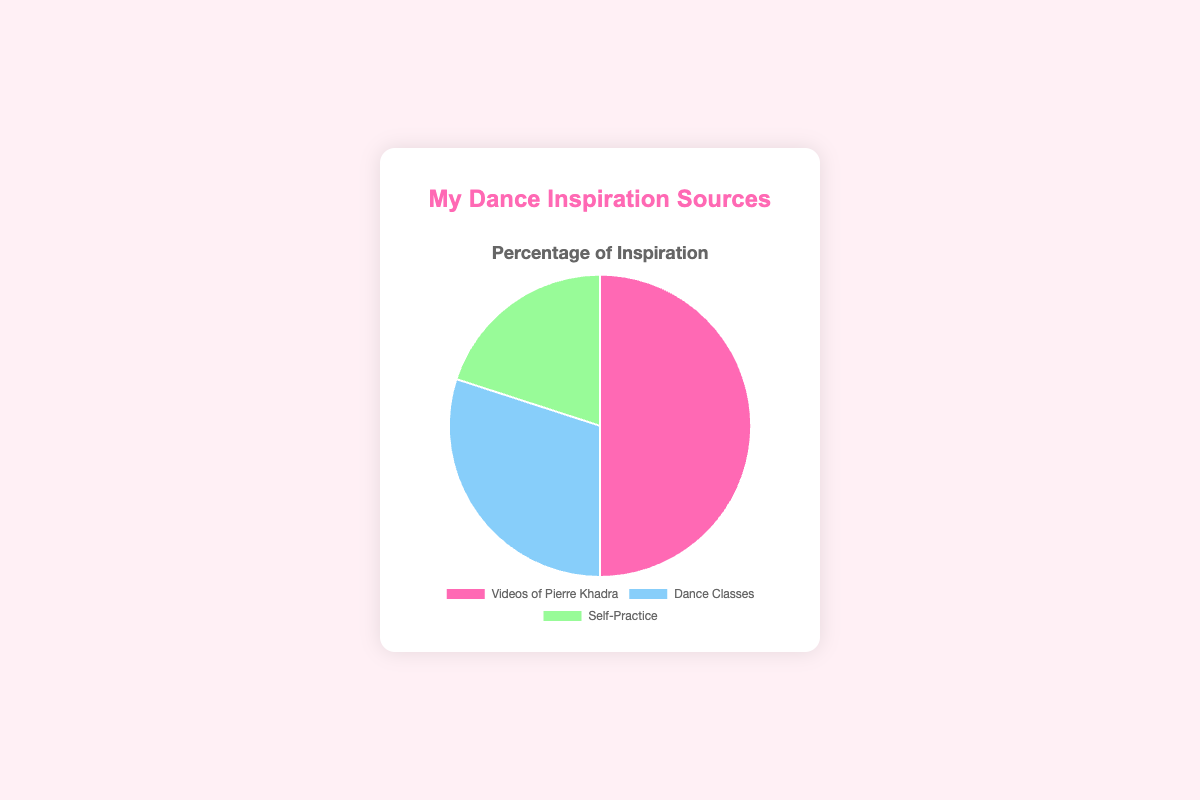Which inspiration source takes up half of the pie chart? The "Videos of Pierre Khadra" segment makes up 50% of the pie chart, representing half of the total data.
Answer: Videos of Pierre Khadra What is the difference in percentage between Dance Classes and Self-Practice? Dance Classes account for 30% and Self-Practice accounts for 20%. Subtracting the two gives the difference: 30% - 20% = 10%.
Answer: 10% What are the colors associated with each inspiration source? The pie chart uses different colors for each segment: Pink for "Videos of Pierre Khadra," Light Blue for "Dance Classes," and Light Green for "Self-Practice."
Answer: Pink, Light Blue, Light Green What percentage of my dance inspiration comes from sources other than Videos of Pierre Khadra? To find the percentage from other sources, add the percentages of Dance Classes and Self-Practice: 30% + 20% = 50%.
Answer: 50% Which inspiration source has the smallest segment in the pie chart? The segment for "Self-Practice" is the smallest, making up 20% of the pie chart.
Answer: Self-Practice What is the combined percentage of inspiration from Dance Classes and Videos of Pierre Khadra? Adding the percentages of Dance Classes (30%) and Videos of Pierre Khadra (50%) gives us: 30% + 50% = 80%.
Answer: 80% How much larger is the percentage of inspiration from Videos of Pierre Khadra compared to Self-Practice? The percentage for Videos of Pierre Khadra is 50%, and for Self-Practice, it is 20%. The difference is 50% - 20% = 30%.
Answer: 30% If you combined Dance Classes and Self-Practice, would their percentage be more than that of Videos of Pierre Khadra alone? The combined percentage of Dance Classes and Self-Practice is 30% + 20% = 50%, which equals the percentage of Videos of Pierre Khadra.
Answer: No Which color represents the largest segment in the pie chart? The pink segment, representing "Videos of Pierre Khadra," is the largest at 50%.
Answer: Pink 